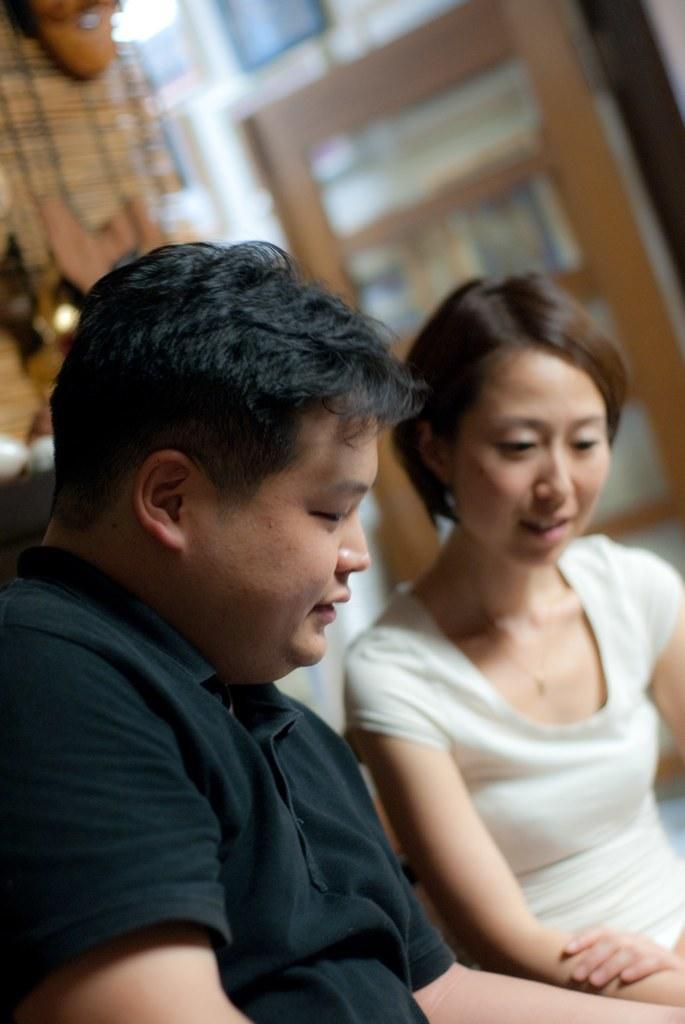How many people are in the image? There are two people in the image, a man and a woman. What is the man wearing in the image? The man is wearing a black t-shirt in the image. Can you describe the background of the image? The background of the image is blurry. What type of machine is being used to paint the flag in the image? There is no machine or flag present in the image. 